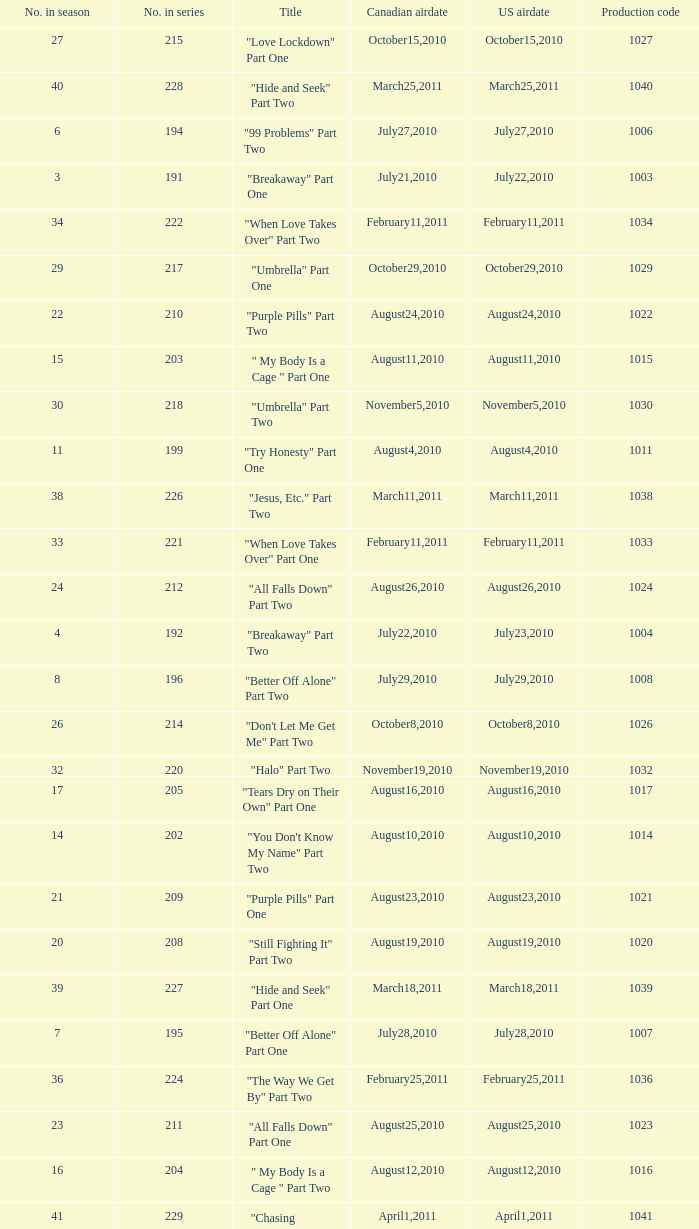What was the us airdate of "love lockdown" part one? October15,2010. 